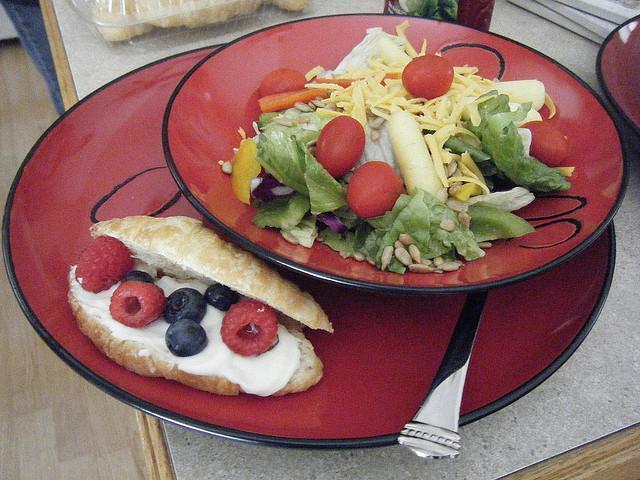How many train cars are painted black?
Give a very brief answer. 0. 